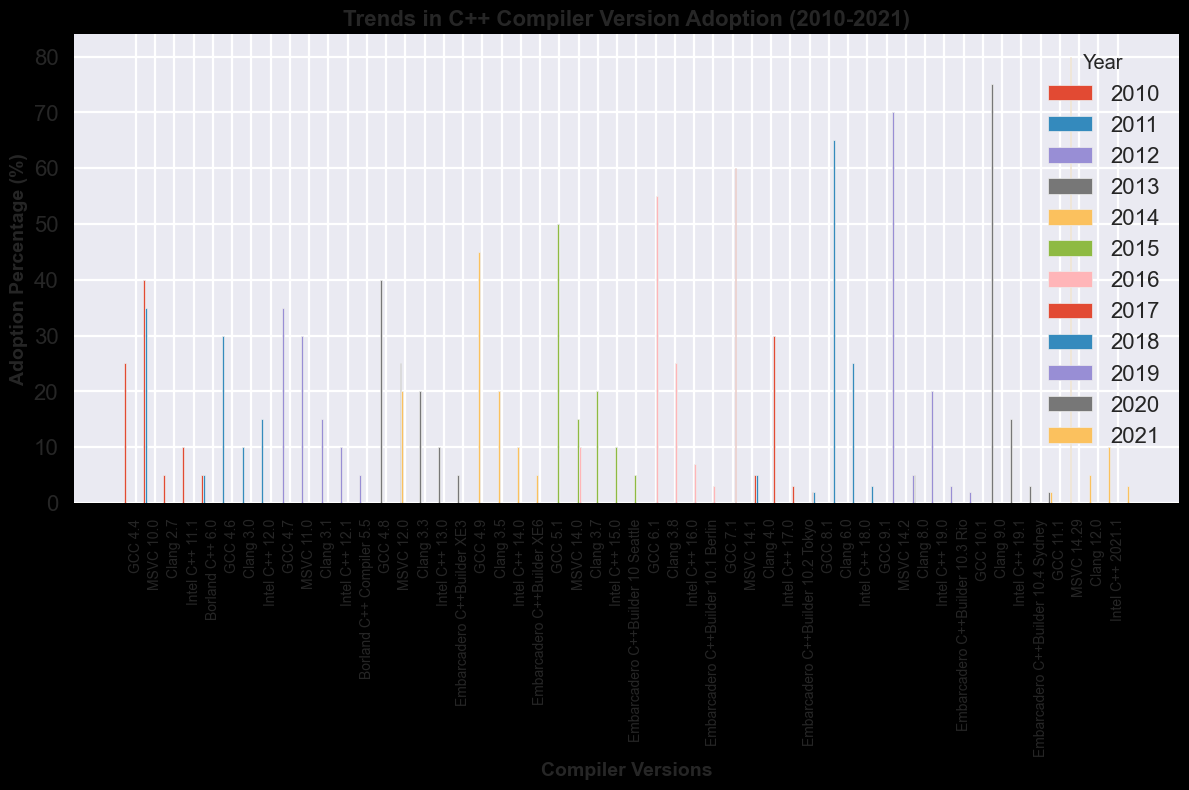What is the trend of GCC adoption from 2010 to 2021? Observing the heights of the bars for each year corresponding to the GCC compiler versions, we see a consistent upward trend. The adoption percentage increases steadily every year from 25% in 2010 to 80% in 2021.
Answer: Increasing Which year did Clang see the highest adoption percentage? By comparing the height of the bars representing Clang across all years, we find that the highest percentage, 30%, occurred in 2017.
Answer: 2017 How did MSVC adoption change over the years? The heights of the bars representing MSVC show a declining trend. MSVC started at 40% in 2010 and decreased gradually to 5% from 2017 onwards.
Answer: Decreasing Which compiler had the highest adoption percentage in 2014? Looking at the heights of the bars for the year 2014, GCC has the highest adoption percentage at 45%.
Answer: GCC What was the combined adoption percentage of Intel C++ versions in 2015 and 2016? The bar heights for Intel C++ in 2015 and 2016 are 10% and 7% respectively. Adding these gives 10 + 7 = 17.
Answer: 17% In which year did Embarcadero C++Builder see a decrease in adoption percentage? Comparing the heights of the bars for Embarcadero C++Builder over the years, we see a decrease from 5% in 2015 to 3% in 2016.
Answer: 2016 Did Clang have a higher adoption percentage than MSVC in 2018? Observing the bar heights for 2018, the Clang adoption percentage is 25%, whereas MSVC’s is 5%. Therefore, Clang had a higher adoption percentage.
Answer: Yes What is the difference between the highest and lowest adoption percentages of Clang over the decade? The highest adoption for Clang was 30% in 2017, and the lowest was 5% in 2010. The difference is 30 - 5 = 25.
Answer: 25% How did the adoption percentage of Intel C++ change between 2012 and 2013? The bar heights for Intel C++ in 2012 and 2013 are 10% and 10% respectively, indicating no change over this period.
Answer: No change Which year had the lowest combined adoption percentage across all compilers? Summing the adoption percentages for each year and comparing, 2021 has the lowest combined adoption at 80 (GCC) + 5 (MSVC) + 10 (Clang) + 3 (Intel C++) + 2 (Embarcadero C++Builder) = 100%.
Answer: 2021 